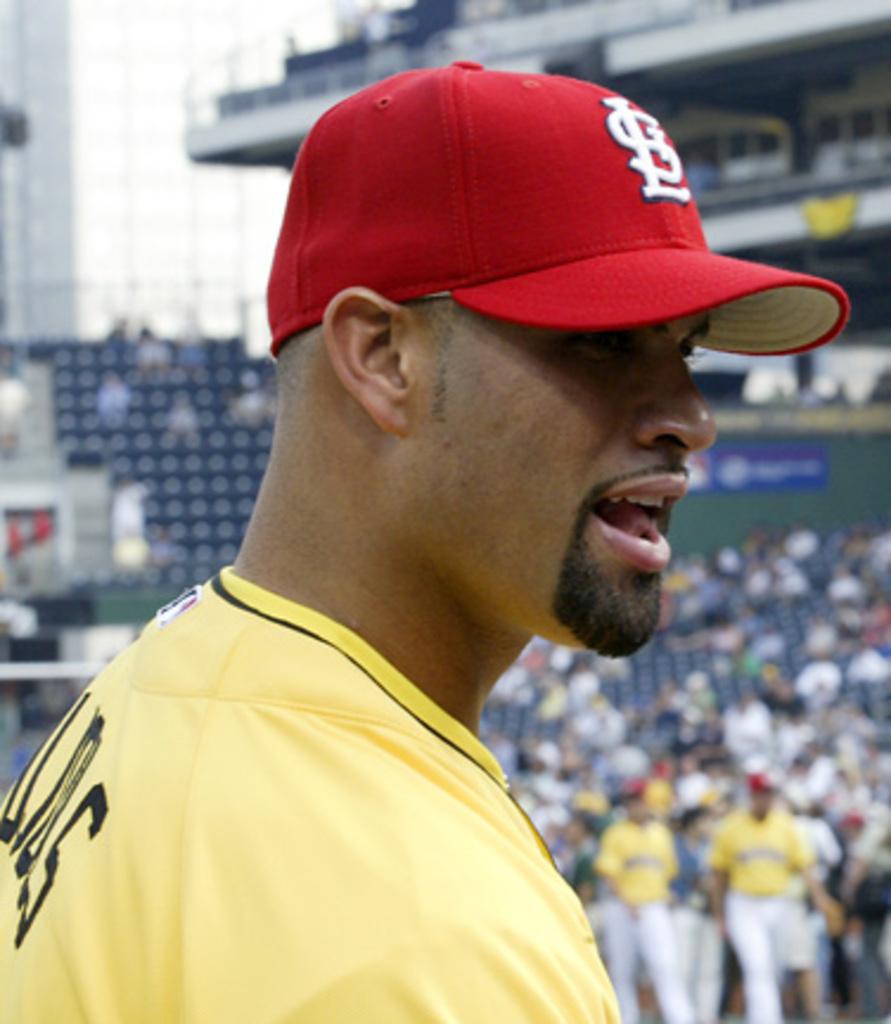What letters are on his hat?
Your response must be concise. Sl. 